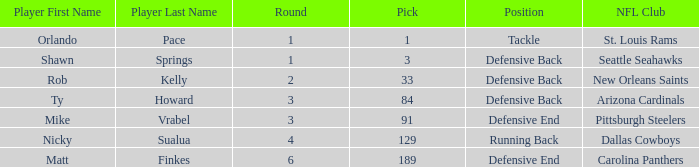Write the full table. {'header': ['Player First Name', 'Player Last Name', 'Round', 'Pick', 'Position', 'NFL Club'], 'rows': [['Orlando', 'Pace', '1', '1', 'Tackle', 'St. Louis Rams'], ['Shawn', 'Springs', '1', '3', 'Defensive Back', 'Seattle Seahawks'], ['Rob', 'Kelly', '2', '33', 'Defensive Back', 'New Orleans Saints'], ['Ty', 'Howard', '3', '84', 'Defensive Back', 'Arizona Cardinals'], ['Mike', 'Vrabel', '3', '91', 'Defensive End', 'Pittsburgh Steelers'], ['Nicky', 'Sualua', '4', '129', 'Running Back', 'Dallas Cowboys'], ['Matt', 'Finkes', '6', '189', 'Defensive End', 'Carolina Panthers']]} What is the lowest pick that has arizona cardinals as the NFL club? 84.0. 